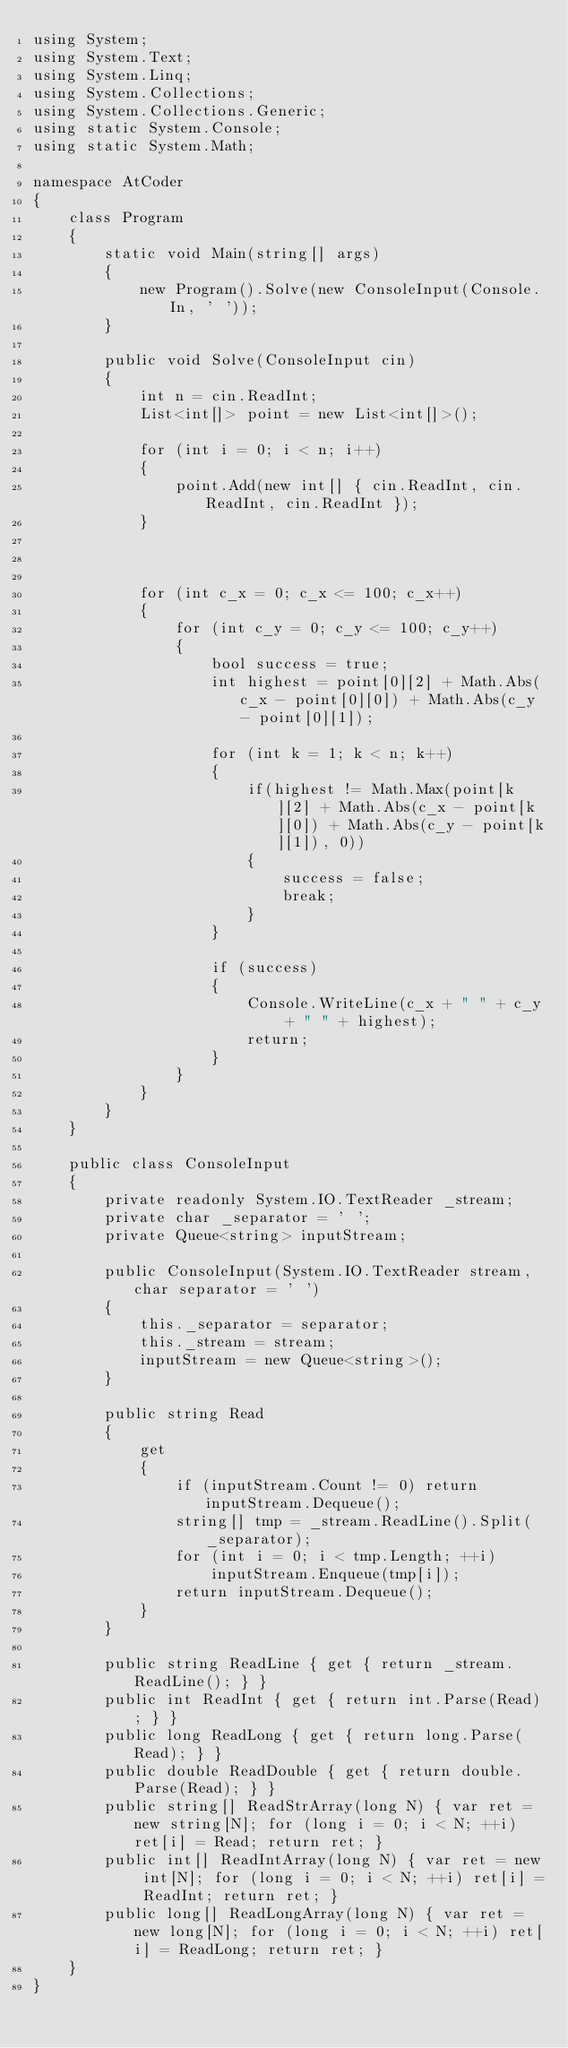Convert code to text. <code><loc_0><loc_0><loc_500><loc_500><_C#_>using System;
using System.Text;
using System.Linq;
using System.Collections;
using System.Collections.Generic;
using static System.Console;
using static System.Math;

namespace AtCoder
{
    class Program
    {
        static void Main(string[] args)
        {
            new Program().Solve(new ConsoleInput(Console.In, ' '));
        }

        public void Solve(ConsoleInput cin)
        {
            int n = cin.ReadInt;
            List<int[]> point = new List<int[]>();

            for (int i = 0; i < n; i++)
            {
                point.Add(new int[] { cin.ReadInt, cin.ReadInt, cin.ReadInt });
            }



            for (int c_x = 0; c_x <= 100; c_x++)
            {
                for (int c_y = 0; c_y <= 100; c_y++)
                {
                    bool success = true;
                    int highest = point[0][2] + Math.Abs(c_x - point[0][0]) + Math.Abs(c_y - point[0][1]);

                    for (int k = 1; k < n; k++)
                    {
                        if(highest != Math.Max(point[k][2] + Math.Abs(c_x - point[k][0]) + Math.Abs(c_y - point[k][1]), 0))
                        {
                            success = false;
                            break;
                        }
                    }

                    if (success)
                    {
                        Console.WriteLine(c_x + " " + c_y + " " + highest);
                        return;
                    }
                }
            }
        }
    }

    public class ConsoleInput
    {
        private readonly System.IO.TextReader _stream;
        private char _separator = ' ';
        private Queue<string> inputStream;

        public ConsoleInput(System.IO.TextReader stream, char separator = ' ')
        {
            this._separator = separator;
            this._stream = stream;
            inputStream = new Queue<string>();
        }

        public string Read
        {
            get
            {
                if (inputStream.Count != 0) return inputStream.Dequeue();
                string[] tmp = _stream.ReadLine().Split(_separator);
                for (int i = 0; i < tmp.Length; ++i)
                    inputStream.Enqueue(tmp[i]);
                return inputStream.Dequeue();
            }
        }

        public string ReadLine { get { return _stream.ReadLine(); } }
        public int ReadInt { get { return int.Parse(Read); } }
        public long ReadLong { get { return long.Parse(Read); } }
        public double ReadDouble { get { return double.Parse(Read); } }
        public string[] ReadStrArray(long N) { var ret = new string[N]; for (long i = 0; i < N; ++i) ret[i] = Read; return ret; }
        public int[] ReadIntArray(long N) { var ret = new int[N]; for (long i = 0; i < N; ++i) ret[i] = ReadInt; return ret; }
        public long[] ReadLongArray(long N) { var ret = new long[N]; for (long i = 0; i < N; ++i) ret[i] = ReadLong; return ret; }
    }
}
</code> 